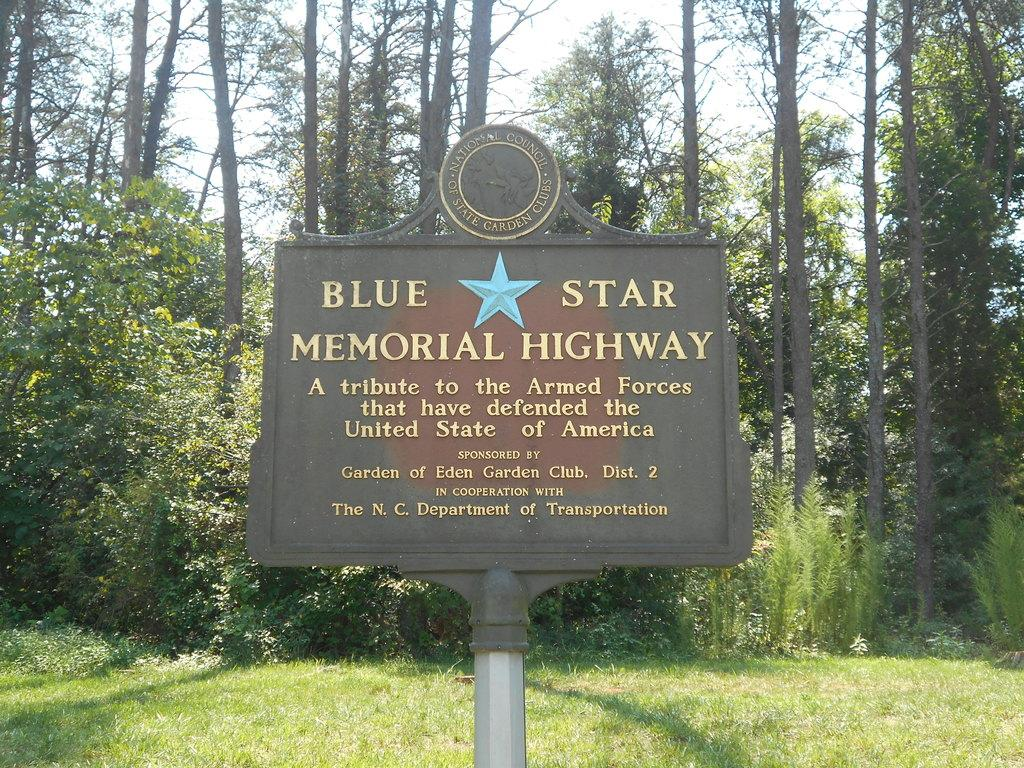What is located in the foreground of the image? There is a board in the foreground of the image. What can be seen in the background of the image? There are trees and plants in the background of the image. What is visible in the sky in the image? The sky is visible in the background of the image. What type of drink is being served in the image? There is no drink present in the image; it only features a board in the foreground and trees, plants, and the sky in the background. 